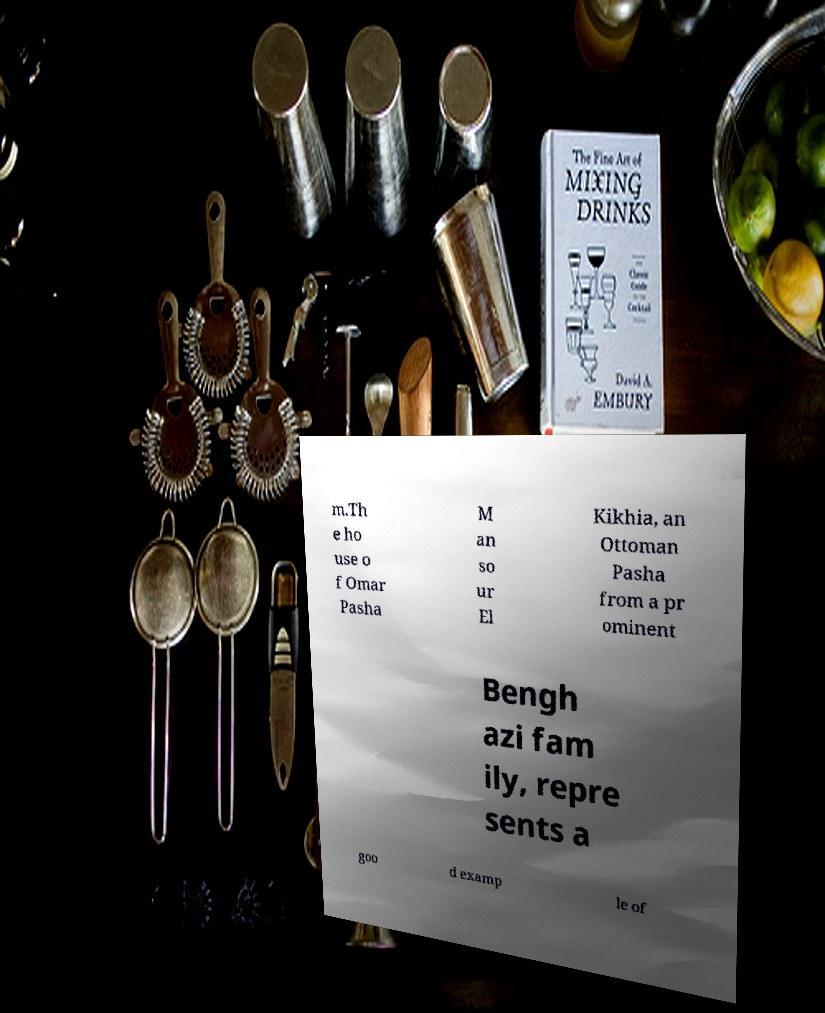For documentation purposes, I need the text within this image transcribed. Could you provide that? m.Th e ho use o f Omar Pasha M an so ur El Kikhia, an Ottoman Pasha from a pr ominent Bengh azi fam ily, repre sents a goo d examp le of 